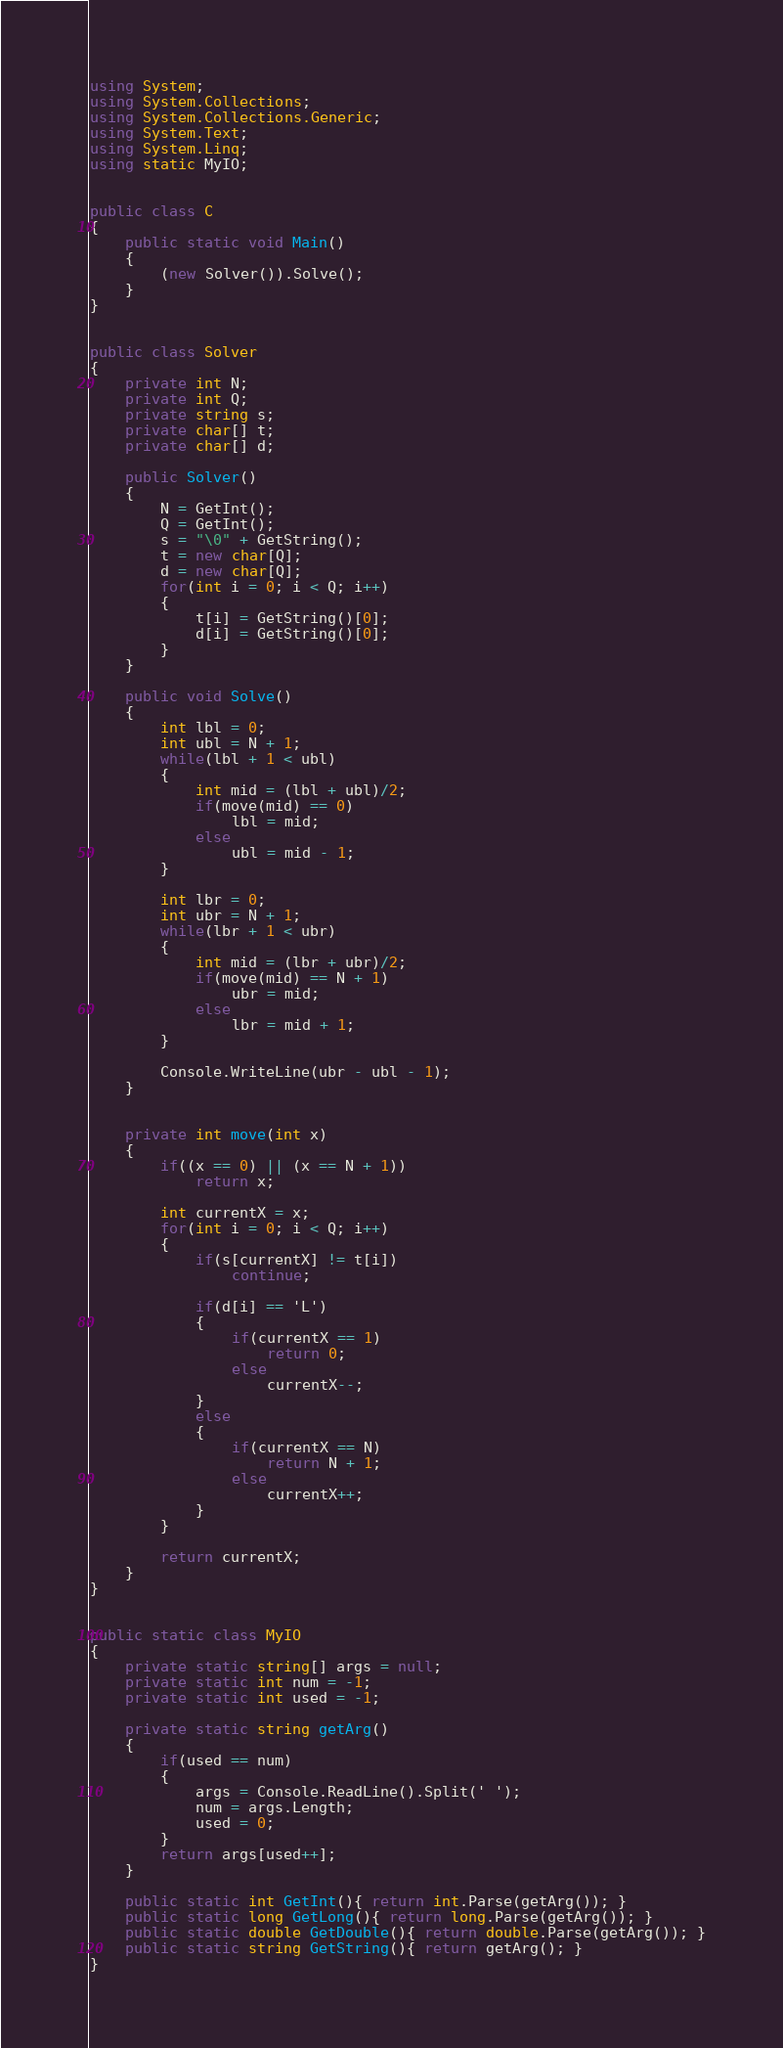Convert code to text. <code><loc_0><loc_0><loc_500><loc_500><_C#_>using System;
using System.Collections;
using System.Collections.Generic;
using System.Text;
using System.Linq;
using static MyIO;


public class C
{
	public static void Main()
	{
		(new Solver()).Solve();
	}	
}


public class Solver
{
	private int N;
	private int Q;
	private string s;
	private char[] t;
	private char[] d;

	public Solver()
	{
		N = GetInt();
		Q = GetInt();
		s = "\0" + GetString();
		t = new char[Q];
		d = new char[Q];
		for(int i = 0; i < Q; i++)
		{
			t[i] = GetString()[0];
			d[i] = GetString()[0];
		}
	}

	public void Solve()
	{
		int lbl = 0;
		int ubl = N + 1;
		while(lbl + 1 < ubl)
		{
			int mid = (lbl + ubl)/2;
			if(move(mid) == 0)
				lbl = mid;
			else
				ubl = mid - 1;
		}

		int lbr = 0;
		int ubr = N + 1;
		while(lbr + 1 < ubr)
		{
			int mid = (lbr + ubr)/2;
			if(move(mid) == N + 1)
				ubr = mid;
			else
				lbr = mid + 1;
		}

		Console.WriteLine(ubr - ubl - 1);
	}


	private int move(int x)
	{
		if((x == 0) || (x == N + 1))
			return x;

		int currentX = x;
		for(int i = 0; i < Q; i++)
		{
			if(s[currentX] != t[i])
				continue;

			if(d[i] == 'L')
			{
				if(currentX == 1)
					return 0;
				else	
					currentX--;
			}
			else
			{
				if(currentX == N)
					return N + 1;
				else
					currentX++;
			}
		}

		return currentX;
	}
}


public static class MyIO
{
	private static string[] args = null;
	private static int num = -1;
	private static int used = -1;

	private static string getArg()
	{
		if(used == num)
		{
			args = Console.ReadLine().Split(' ');
			num = args.Length;
			used = 0;
		}
		return args[used++];
	}

	public static int GetInt(){ return int.Parse(getArg()); }
	public static long GetLong(){ return long.Parse(getArg()); }
	public static double GetDouble(){ return double.Parse(getArg()); }
	public static string GetString(){ return getArg(); }
}
</code> 